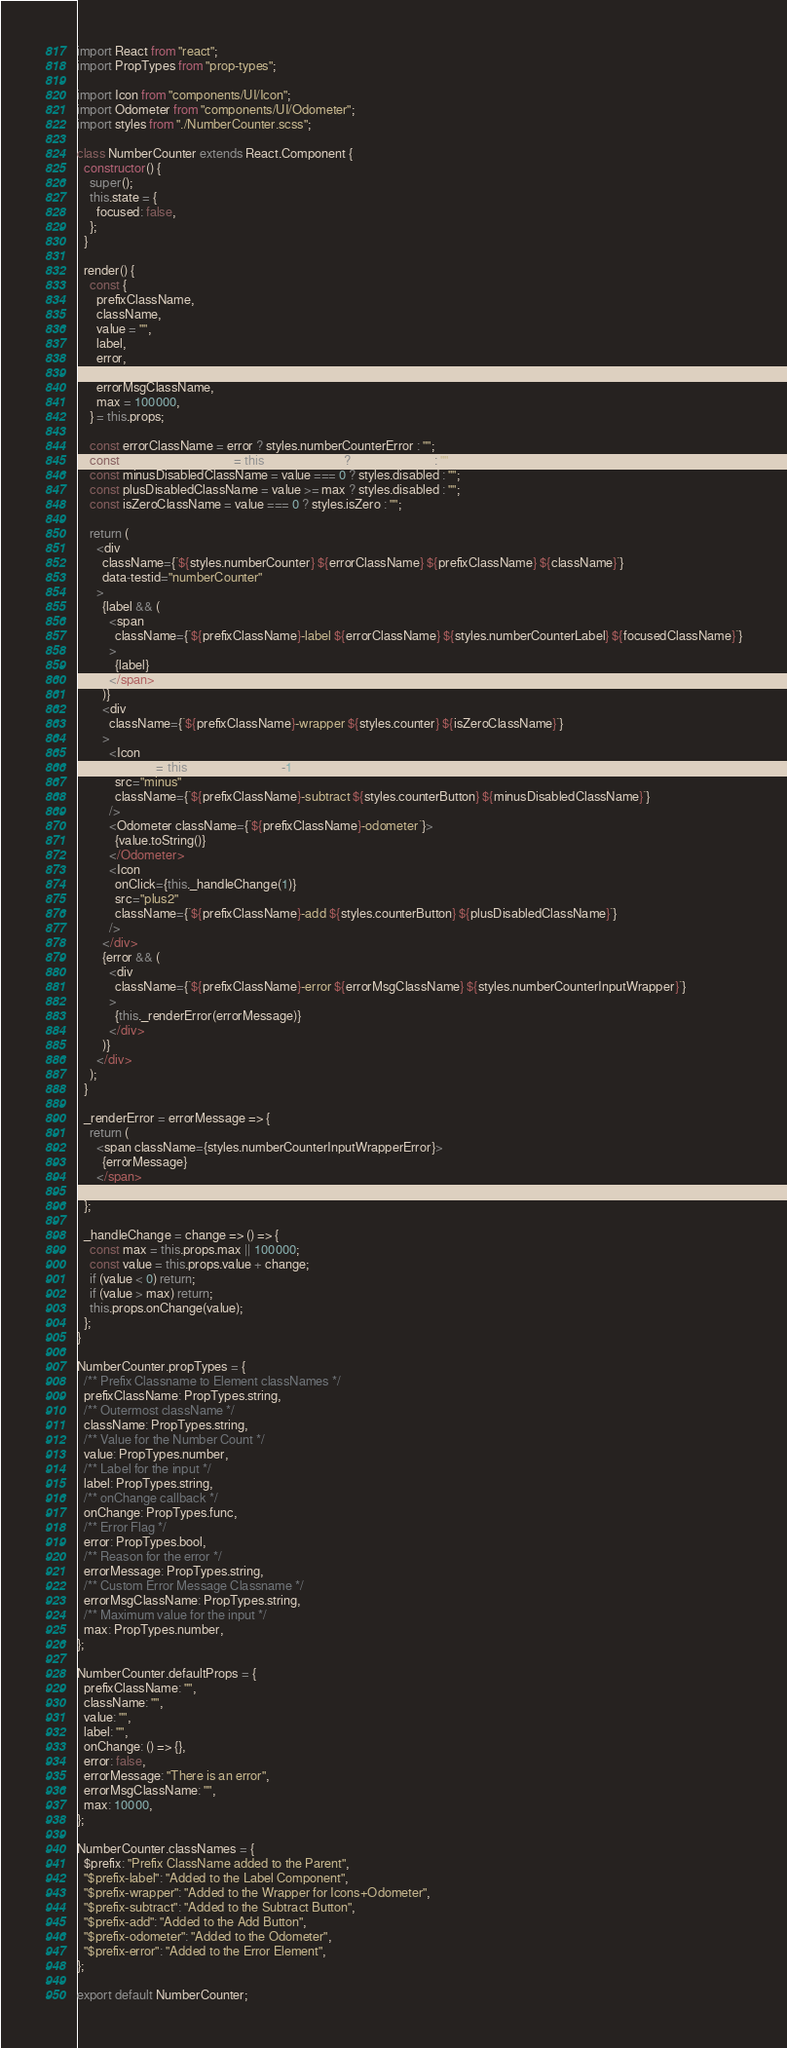Convert code to text. <code><loc_0><loc_0><loc_500><loc_500><_JavaScript_>import React from "react";
import PropTypes from "prop-types";

import Icon from "components/UI/Icon";
import Odometer from "components/UI/Odometer";
import styles from "./NumberCounter.scss";

class NumberCounter extends React.Component {
  constructor() {
    super();
    this.state = {
      focused: false,
    };
  }

  render() {
    const {
      prefixClassName,
      className,
      value = "",
      label,
      error,
      errorMessage,
      errorMsgClassName,
      max = 100000,
    } = this.props;

    const errorClassName = error ? styles.numberCounterError : "";
    const focusedClassName = this.state.focused ? styles.focused : "";
    const minusDisabledClassName = value === 0 ? styles.disabled : "";
    const plusDisabledClassName = value >= max ? styles.disabled : "";
    const isZeroClassName = value === 0 ? styles.isZero : "";

    return (
      <div
        className={`${styles.numberCounter} ${errorClassName} ${prefixClassName} ${className}`}
        data-testid="numberCounter"
      >
        {label && (
          <span
            className={`${prefixClassName}-label ${errorClassName} ${styles.numberCounterLabel} ${focusedClassName}`}
          >
            {label}
          </span>
        )}
        <div
          className={`${prefixClassName}-wrapper ${styles.counter} ${isZeroClassName}`}
        >
          <Icon
            onClick={this._handleChange(-1)}
            src="minus"
            className={`${prefixClassName}-subtract ${styles.counterButton} ${minusDisabledClassName}`}
          />
          <Odometer className={`${prefixClassName}-odometer`}>
            {value.toString()}
          </Odometer>
          <Icon
            onClick={this._handleChange(1)}
            src="plus2"
            className={`${prefixClassName}-add ${styles.counterButton} ${plusDisabledClassName}`}
          />
        </div>
        {error && (
          <div
            className={`${prefixClassName}-error ${errorMsgClassName} ${styles.numberCounterInputWrapper}`}
          >
            {this._renderError(errorMessage)}
          </div>
        )}
      </div>
    );
  }

  _renderError = errorMessage => {
    return (
      <span className={styles.numberCounterInputWrapperError}>
        {errorMessage}
      </span>
    );
  };

  _handleChange = change => () => {
    const max = this.props.max || 100000;
    const value = this.props.value + change;
    if (value < 0) return;
    if (value > max) return;
    this.props.onChange(value);
  };
}

NumberCounter.propTypes = {
  /** Prefix Classname to Element classNames */
  prefixClassName: PropTypes.string,
  /** Outermost className */
  className: PropTypes.string,
  /** Value for the Number Count */
  value: PropTypes.number,
  /** Label for the input */
  label: PropTypes.string,
  /** onChange callback */
  onChange: PropTypes.func,
  /** Error Flag */
  error: PropTypes.bool,
  /** Reason for the error */
  errorMessage: PropTypes.string,
  /** Custom Error Message Classname */
  errorMsgClassName: PropTypes.string,
  /** Maximum value for the input */
  max: PropTypes.number,
};

NumberCounter.defaultProps = {
  prefixClassName: "",
  className: "",
  value: "",
  label: "",
  onChange: () => {},
  error: false,
  errorMessage: "There is an error",
  errorMsgClassName: "",
  max: 10000,
};

NumberCounter.classNames = {
  $prefix: "Prefix ClassName added to the Parent",
  "$prefix-label": "Added to the Label Component",
  "$prefix-wrapper": "Added to the Wrapper for Icons+Odometer",
  "$prefix-subtract": "Added to the Subtract Button",
  "$prefix-add": "Added to the Add Button",
  "$prefix-odometer": "Added to the Odometer",
  "$prefix-error": "Added to the Error Element",
};

export default NumberCounter;
</code> 